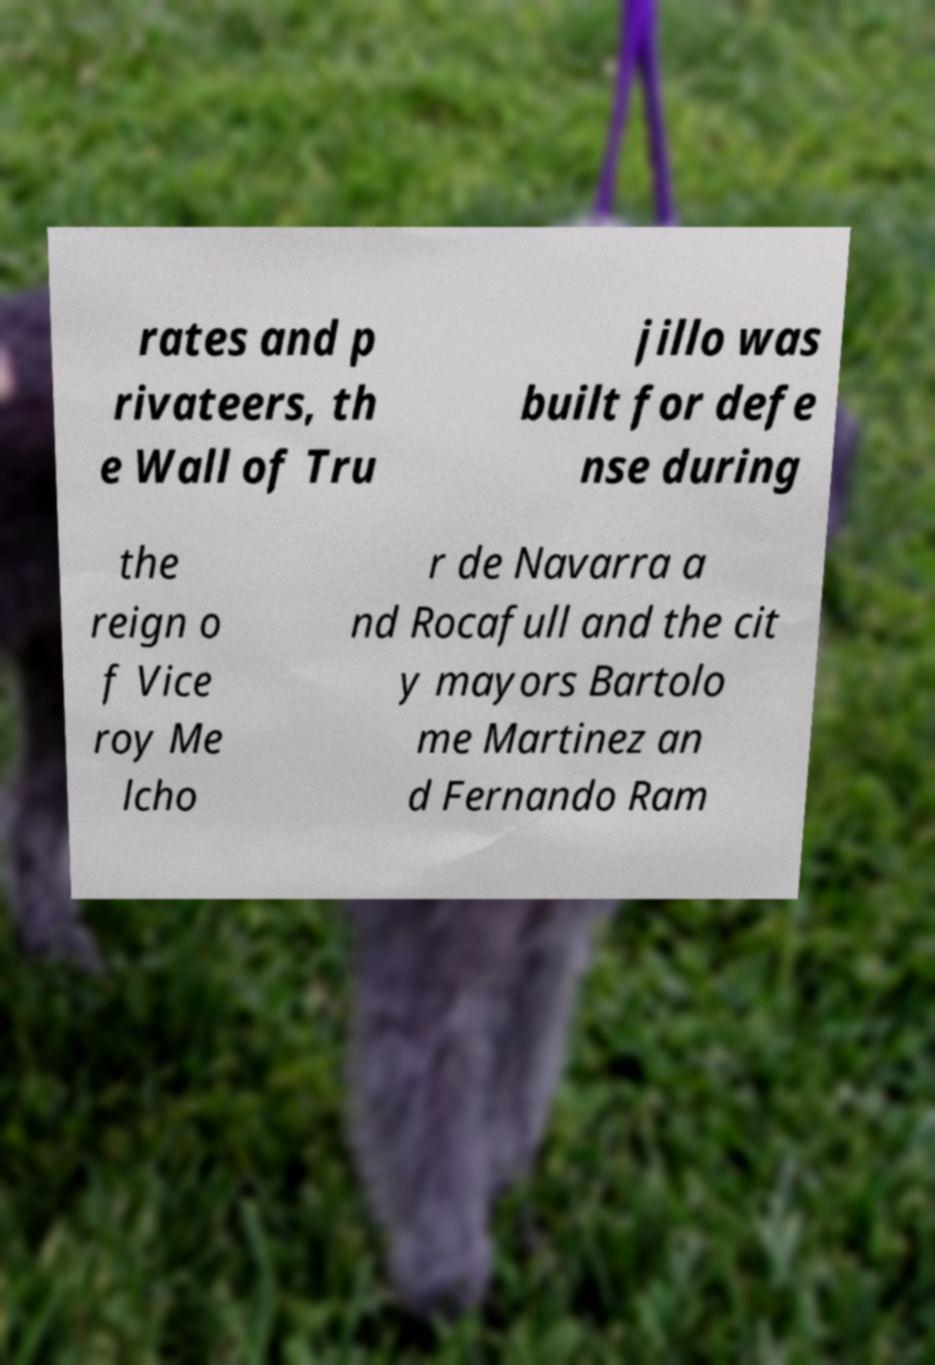Please read and relay the text visible in this image. What does it say? rates and p rivateers, th e Wall of Tru jillo was built for defe nse during the reign o f Vice roy Me lcho r de Navarra a nd Rocafull and the cit y mayors Bartolo me Martinez an d Fernando Ram 